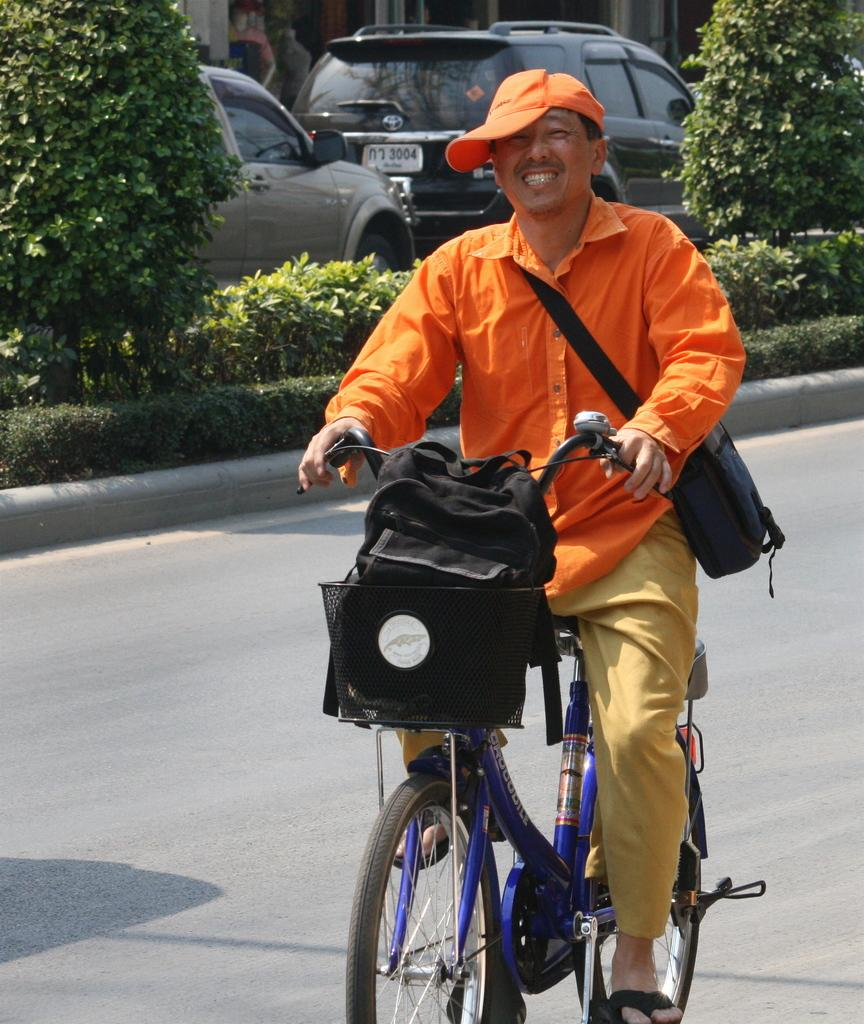What is the man in the image doing? The man is on a bicycle in the image. What is the setting of the image? There is a road in the image. What can be seen in the background of the image? There are plants visible in the image. What else is present on the road in the image? There are vehicles on the road in the image. How many pies are being baked in the field in the image? There is no field or pies present in the image; it features a man on a bicycle on a road with plants and vehicles. 